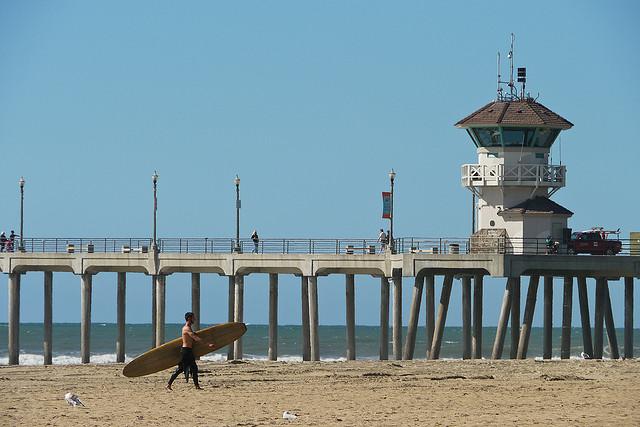What is the man carrying?
Give a very brief answer. Surfboard. What is the long structure called?
Write a very short answer. Pier. Is it sunny?
Keep it brief. Yes. How many birds are on the beach?
Be succinct. 2. 